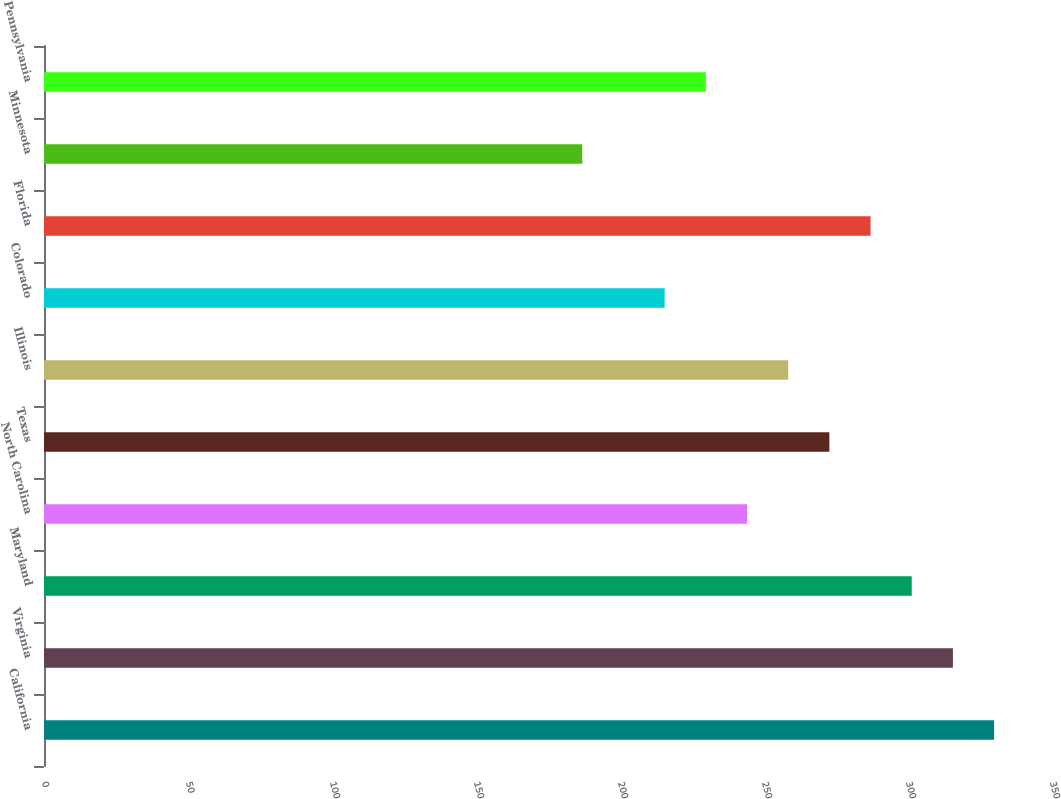Convert chart. <chart><loc_0><loc_0><loc_500><loc_500><bar_chart><fcel>California<fcel>Virginia<fcel>Maryland<fcel>North Carolina<fcel>Texas<fcel>Illinois<fcel>Colorado<fcel>Florida<fcel>Minnesota<fcel>Pennsylvania<nl><fcel>329.9<fcel>315.6<fcel>301.3<fcel>244.1<fcel>272.7<fcel>258.4<fcel>215.5<fcel>287<fcel>186.9<fcel>229.8<nl></chart> 